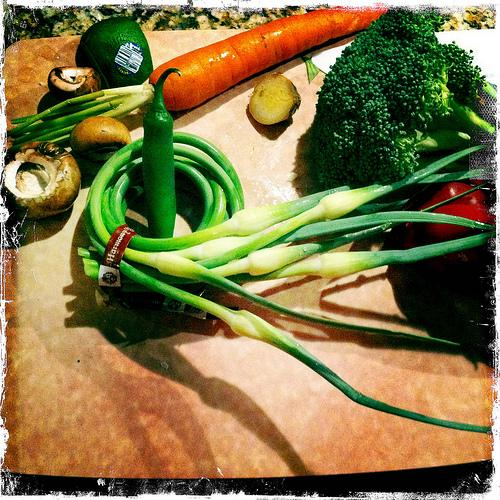Mention a task that would require understanding the connection between visuals and textual description. Visual entailment task Choose a suitable tagline for a product advertisement featuring these vegetables. "Fresh, vibrant, nutritious - nature's bounty for a healthy life!" In a few words, describe the setting where these vegetables are placed. Vegetables on a brown cutting board Imagine you're an announcer on a cooking show. Describe these veggies as a part of a new recipe. "Today, we have a delightful assortment of fresh vegetables! Green peppers, carrots, broccoli, and more, all waiting to create a delicious and nutritious meal." What type of task could involve identifying the specific dietary items on this brown board? Referential expression grounding task If promoting this colorful spread, which multi-choice task would be fitting to determine the correct arrangement? Multi-choice VQA task Identify the type of vegetable next to the carrots. Green pepper What type of vegetables are in the bowl at X:16 Y:22 with Width:466 Height:466? No, it's not mentioned in the image. 